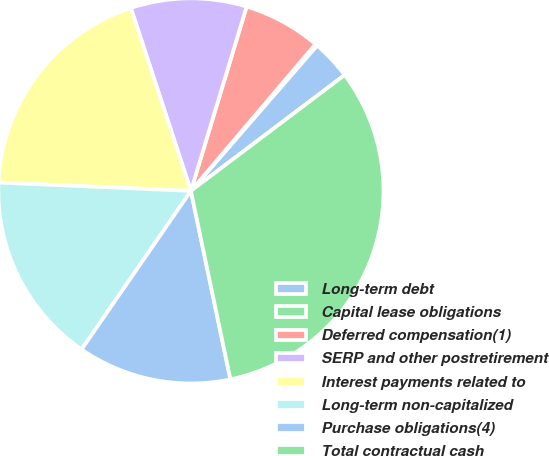Convert chart. <chart><loc_0><loc_0><loc_500><loc_500><pie_chart><fcel>Long-term debt<fcel>Capital lease obligations<fcel>Deferred compensation(1)<fcel>SERP and other postretirement<fcel>Interest payments related to<fcel>Long-term non-capitalized<fcel>Purchase obligations(4)<fcel>Total contractual cash<nl><fcel>3.35%<fcel>0.17%<fcel>6.53%<fcel>9.72%<fcel>19.26%<fcel>16.08%<fcel>12.9%<fcel>31.99%<nl></chart> 